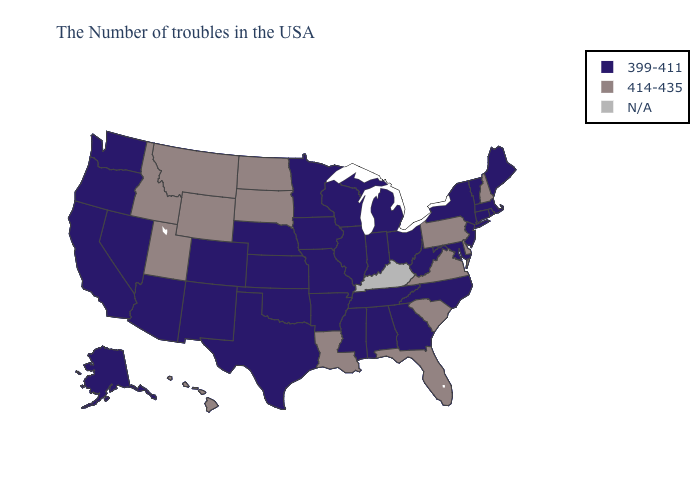What is the highest value in the South ?
Give a very brief answer. 414-435. Among the states that border Ohio , which have the lowest value?
Write a very short answer. West Virginia, Michigan, Indiana. Name the states that have a value in the range 414-435?
Concise answer only. New Hampshire, Delaware, Pennsylvania, Virginia, South Carolina, Florida, Louisiana, South Dakota, North Dakota, Wyoming, Utah, Montana, Idaho, Hawaii. Name the states that have a value in the range N/A?
Be succinct. Kentucky. How many symbols are there in the legend?
Answer briefly. 3. What is the value of Alabama?
Write a very short answer. 399-411. Name the states that have a value in the range N/A?
Concise answer only. Kentucky. Name the states that have a value in the range 399-411?
Keep it brief. Maine, Massachusetts, Rhode Island, Vermont, Connecticut, New York, New Jersey, Maryland, North Carolina, West Virginia, Ohio, Georgia, Michigan, Indiana, Alabama, Tennessee, Wisconsin, Illinois, Mississippi, Missouri, Arkansas, Minnesota, Iowa, Kansas, Nebraska, Oklahoma, Texas, Colorado, New Mexico, Arizona, Nevada, California, Washington, Oregon, Alaska. How many symbols are there in the legend?
Give a very brief answer. 3. What is the value of Wyoming?
Give a very brief answer. 414-435. What is the highest value in the MidWest ?
Concise answer only. 414-435. Name the states that have a value in the range 414-435?
Concise answer only. New Hampshire, Delaware, Pennsylvania, Virginia, South Carolina, Florida, Louisiana, South Dakota, North Dakota, Wyoming, Utah, Montana, Idaho, Hawaii. What is the highest value in the USA?
Keep it brief. 414-435. Name the states that have a value in the range 399-411?
Write a very short answer. Maine, Massachusetts, Rhode Island, Vermont, Connecticut, New York, New Jersey, Maryland, North Carolina, West Virginia, Ohio, Georgia, Michigan, Indiana, Alabama, Tennessee, Wisconsin, Illinois, Mississippi, Missouri, Arkansas, Minnesota, Iowa, Kansas, Nebraska, Oklahoma, Texas, Colorado, New Mexico, Arizona, Nevada, California, Washington, Oregon, Alaska. Among the states that border Utah , which have the lowest value?
Quick response, please. Colorado, New Mexico, Arizona, Nevada. 